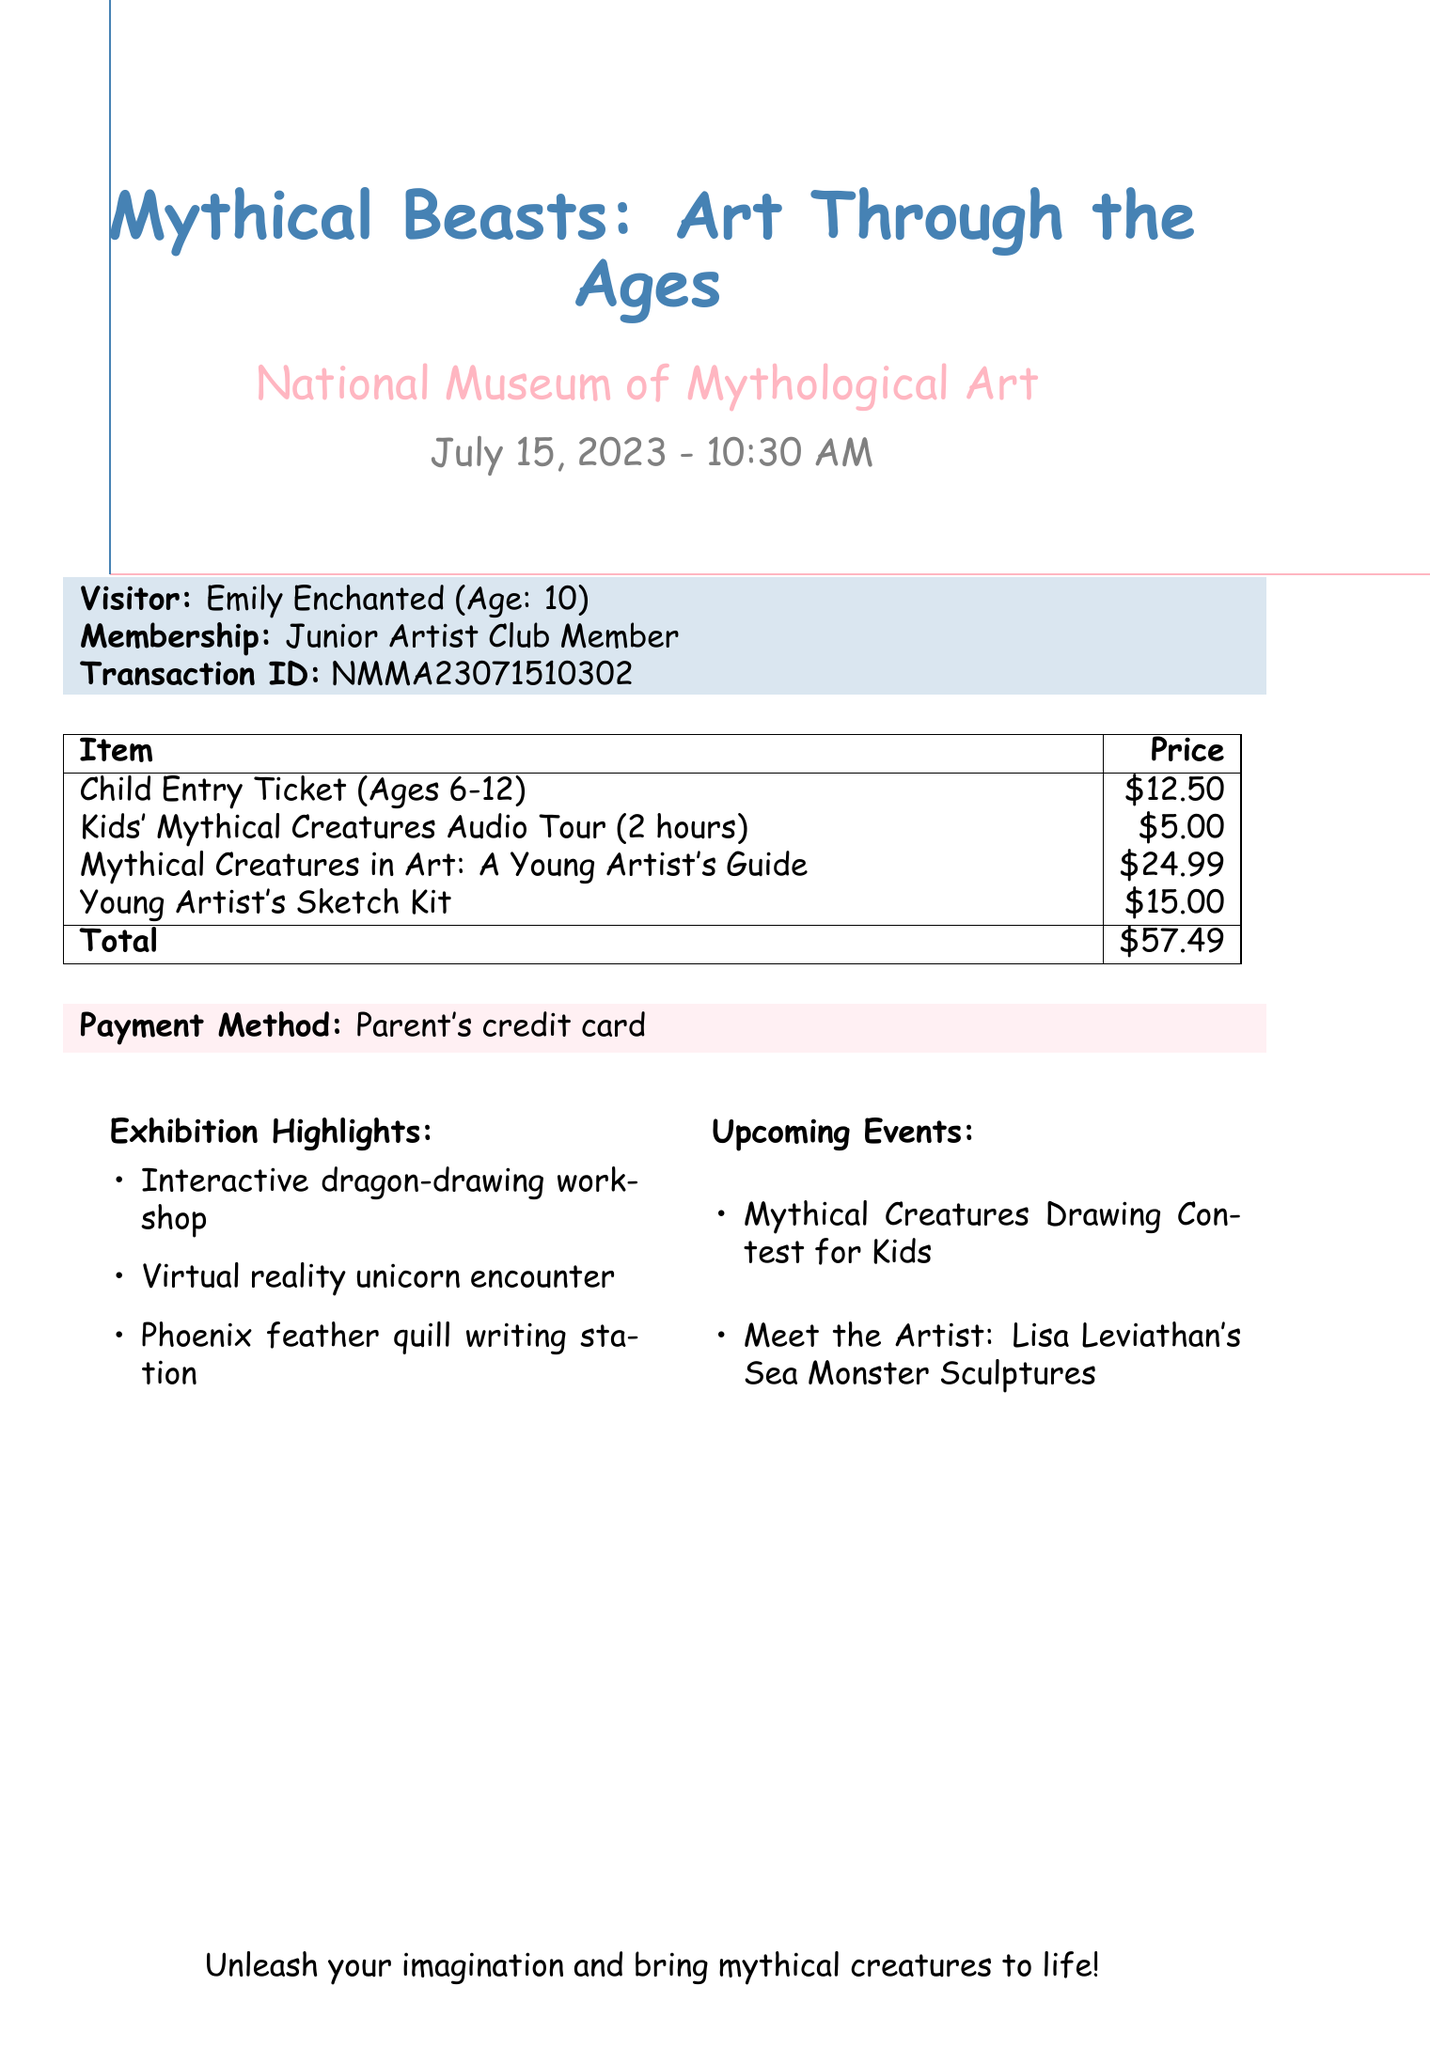What is the event name? The event name is clearly stated in the document, indicating the exhibition's title.
Answer: Mythical Beasts: Art Through the Ages What is the entry fee for a child ticket? The entry fee for a child ticket is listed in the table of items with their respective prices.
Answer: $12.50 Who is the author of the exhibition catalog? The author of the exhibition catalog is mentioned beside the catalog title in the document.
Answer: Dr. Fiona Fairytale What is the total amount paid? The total amount paid is summarized at the end of the itemized list in the document.
Answer: $57.49 What special offer is included in the transaction? The special offer is detailed in the document, specifically listing its name and contents.
Answer: Young Artist's Sketch Kit What is the duration of the audio guide rental? The duration for the audio guide rental is specified in the description of the item in the document.
Answer: 2 hours What payment method was used? The payment method is explicitly mentioned in the payment information section of the document.
Answer: Parent's credit card How old is the visitor? The age of the visitor is clearly indicated next to their name in the visitor's information section.
Answer: 10 What is one of the exhibition highlights? The exhibition highlights are listed in the document, providing insights into activities offered during the event.
Answer: Interactive dragon-drawing workshop 